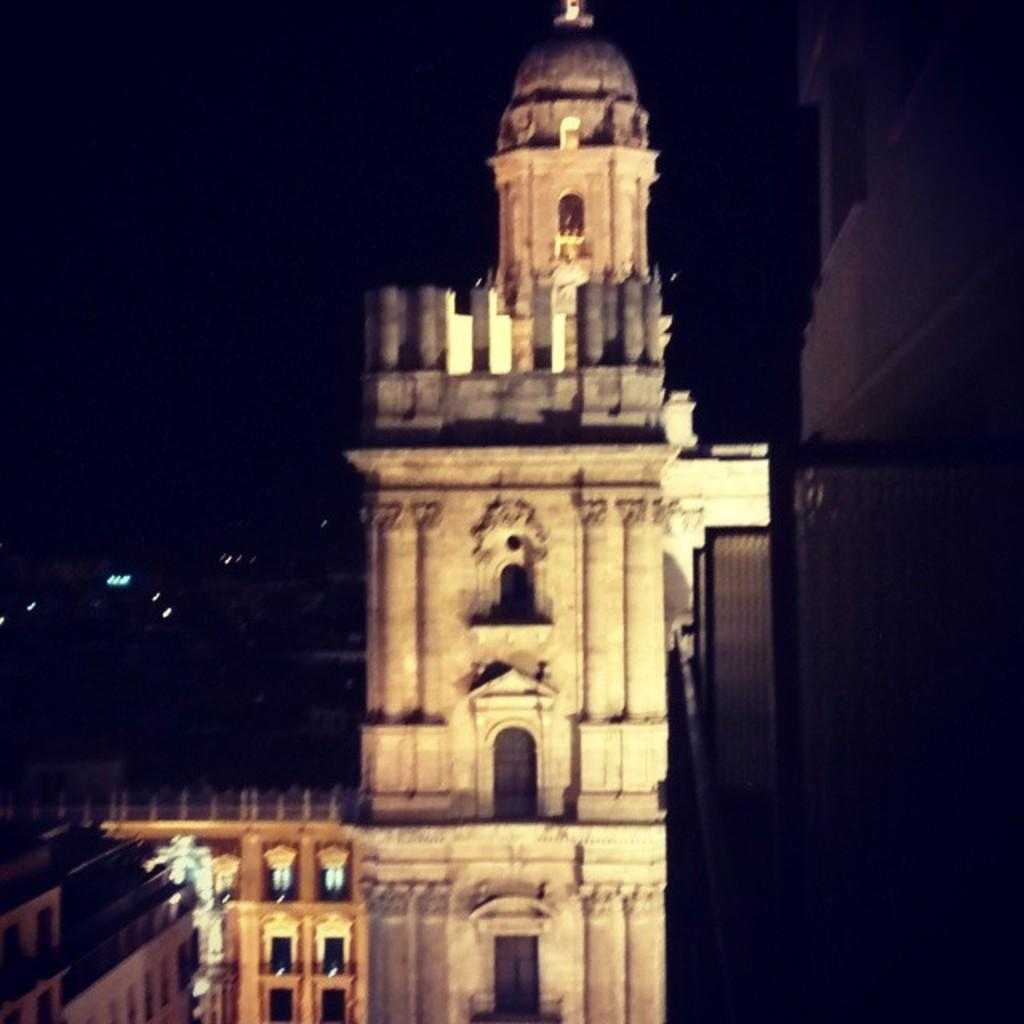What type of structures can be seen in the image? There are buildings in the image. What can be observed illuminating the scene in the image? There are lights visible in the image. What type of milk is being served at the pet competition in the image? There is no milk, pets, or competition present in the image. 